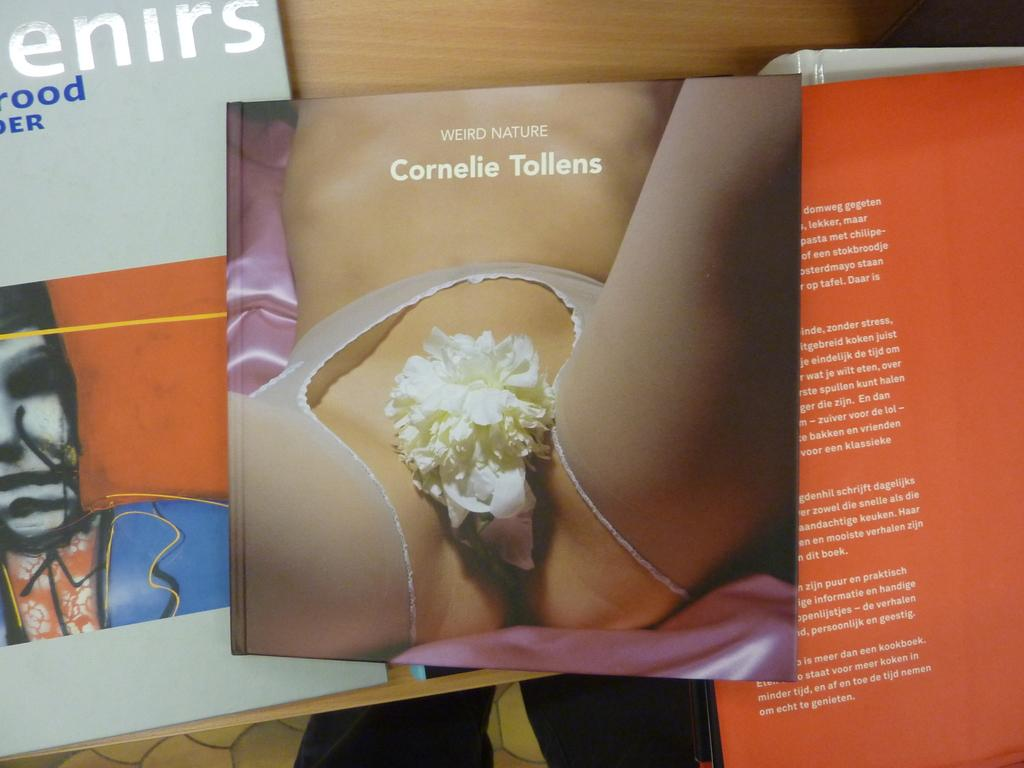<image>
Share a concise interpretation of the image provided. A book called Weird Nature, by Cornelie Tollens, features a woman's body on the cover. 